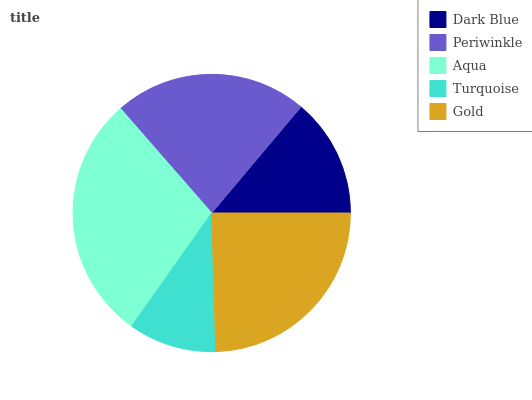Is Turquoise the minimum?
Answer yes or no. Yes. Is Aqua the maximum?
Answer yes or no. Yes. Is Periwinkle the minimum?
Answer yes or no. No. Is Periwinkle the maximum?
Answer yes or no. No. Is Periwinkle greater than Dark Blue?
Answer yes or no. Yes. Is Dark Blue less than Periwinkle?
Answer yes or no. Yes. Is Dark Blue greater than Periwinkle?
Answer yes or no. No. Is Periwinkle less than Dark Blue?
Answer yes or no. No. Is Periwinkle the high median?
Answer yes or no. Yes. Is Periwinkle the low median?
Answer yes or no. Yes. Is Turquoise the high median?
Answer yes or no. No. Is Aqua the low median?
Answer yes or no. No. 